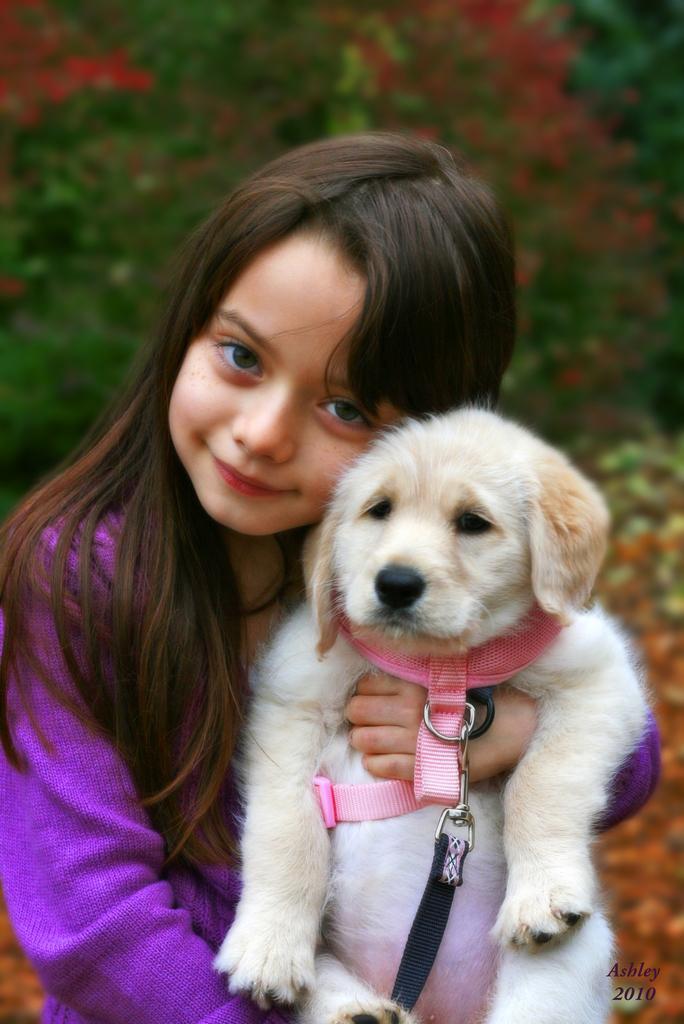Please provide a concise description of this image. In this image we can see a child wearing purple color dress is holding a dog in her hands. In the background of the image we can see trees. 